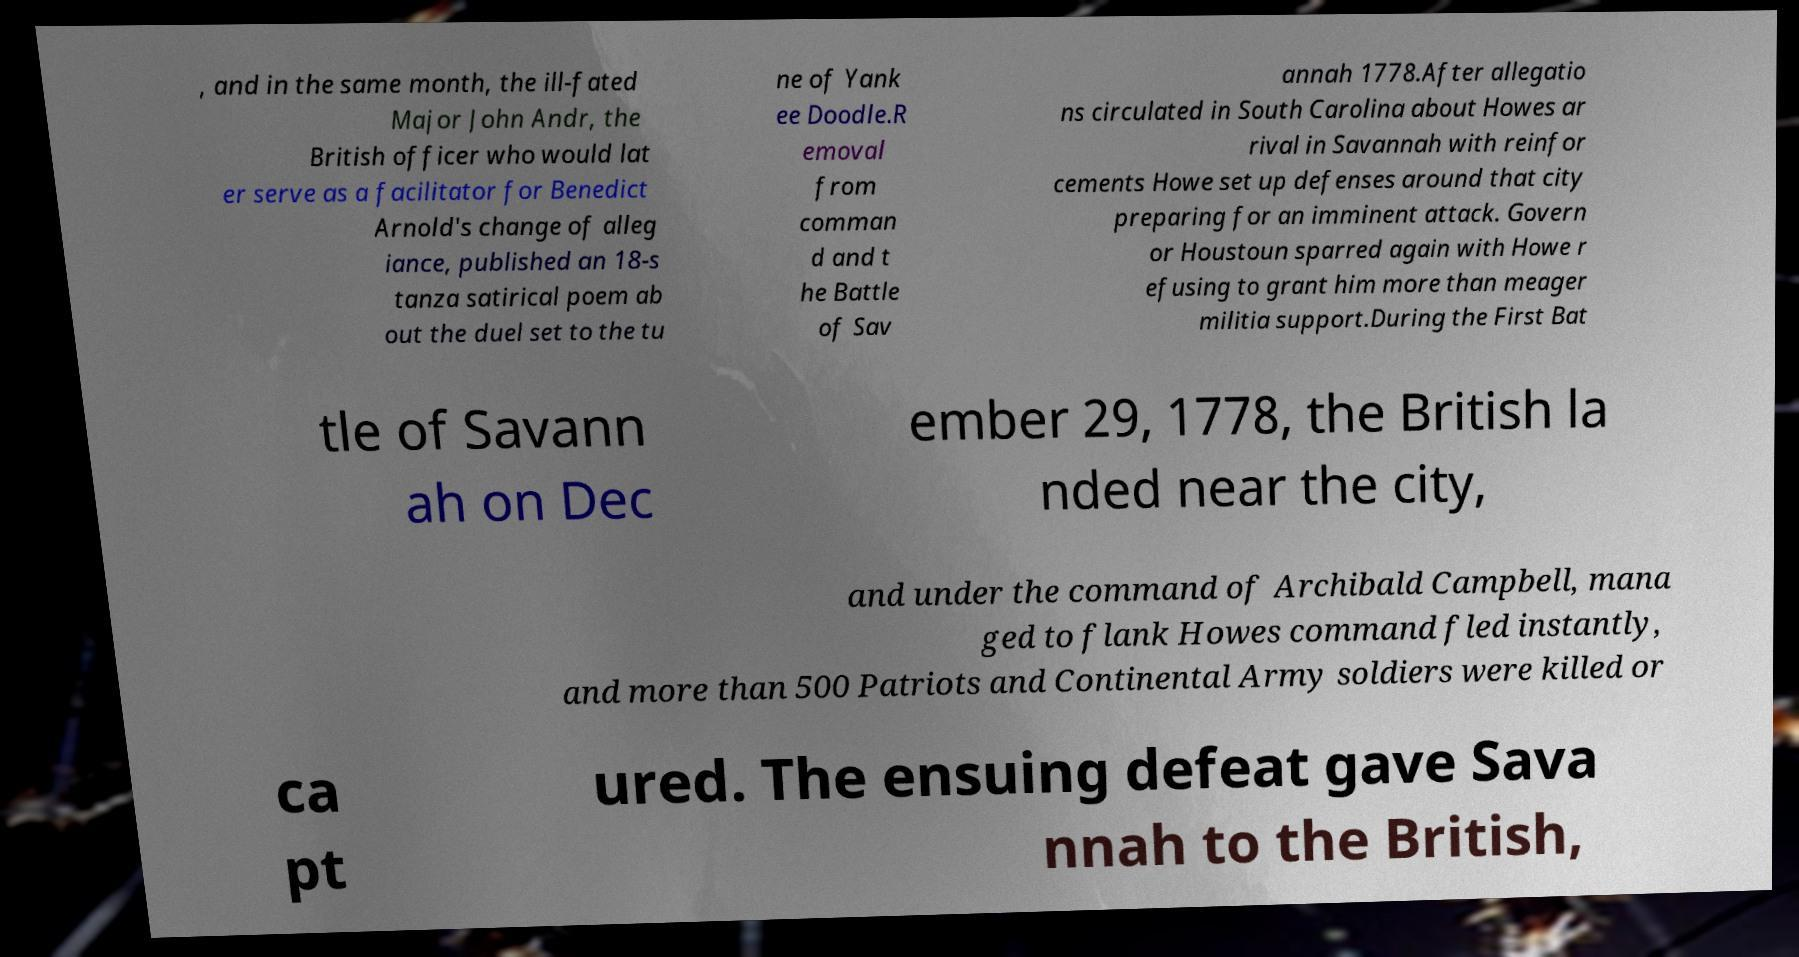What messages or text are displayed in this image? I need them in a readable, typed format. , and in the same month, the ill-fated Major John Andr, the British officer who would lat er serve as a facilitator for Benedict Arnold's change of alleg iance, published an 18-s tanza satirical poem ab out the duel set to the tu ne of Yank ee Doodle.R emoval from comman d and t he Battle of Sav annah 1778.After allegatio ns circulated in South Carolina about Howes ar rival in Savannah with reinfor cements Howe set up defenses around that city preparing for an imminent attack. Govern or Houstoun sparred again with Howe r efusing to grant him more than meager militia support.During the First Bat tle of Savann ah on Dec ember 29, 1778, the British la nded near the city, and under the command of Archibald Campbell, mana ged to flank Howes command fled instantly, and more than 500 Patriots and Continental Army soldiers were killed or ca pt ured. The ensuing defeat gave Sava nnah to the British, 